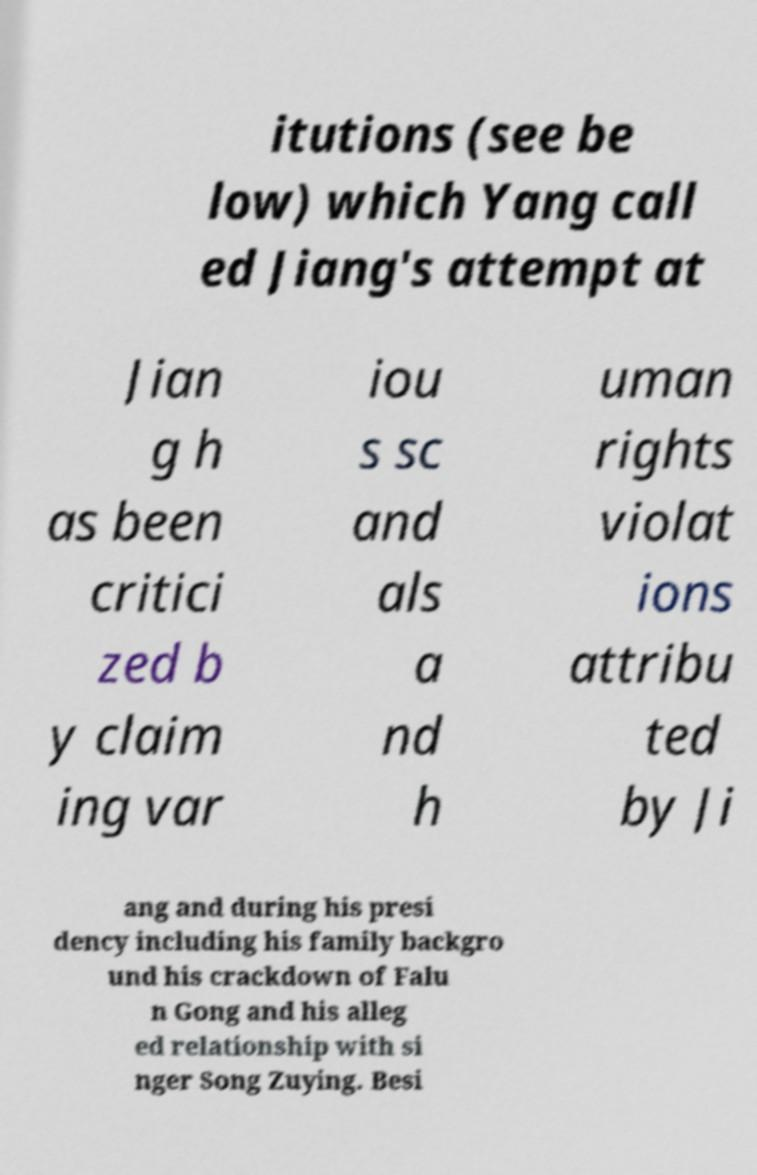For documentation purposes, I need the text within this image transcribed. Could you provide that? itutions (see be low) which Yang call ed Jiang's attempt at Jian g h as been critici zed b y claim ing var iou s sc and als a nd h uman rights violat ions attribu ted by Ji ang and during his presi dency including his family backgro und his crackdown of Falu n Gong and his alleg ed relationship with si nger Song Zuying. Besi 